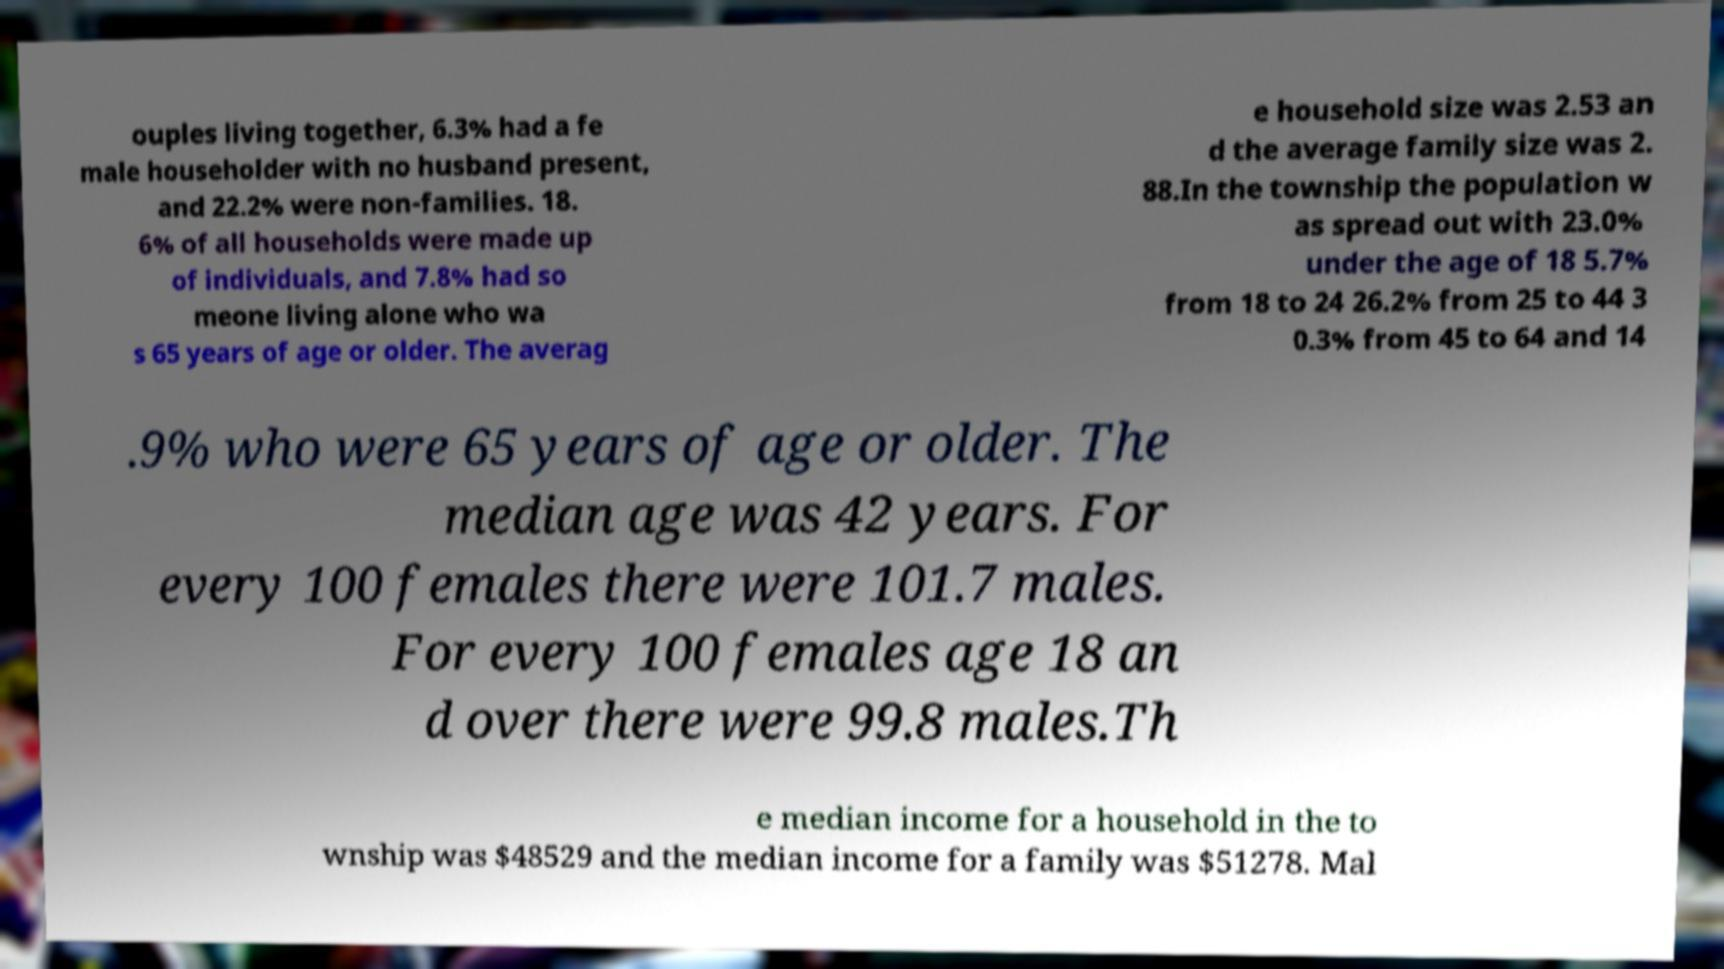Can you accurately transcribe the text from the provided image for me? ouples living together, 6.3% had a fe male householder with no husband present, and 22.2% were non-families. 18. 6% of all households were made up of individuals, and 7.8% had so meone living alone who wa s 65 years of age or older. The averag e household size was 2.53 an d the average family size was 2. 88.In the township the population w as spread out with 23.0% under the age of 18 5.7% from 18 to 24 26.2% from 25 to 44 3 0.3% from 45 to 64 and 14 .9% who were 65 years of age or older. The median age was 42 years. For every 100 females there were 101.7 males. For every 100 females age 18 an d over there were 99.8 males.Th e median income for a household in the to wnship was $48529 and the median income for a family was $51278. Mal 